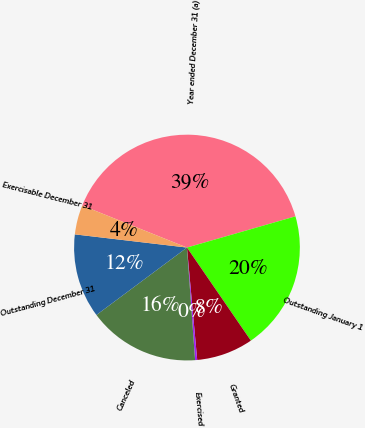<chart> <loc_0><loc_0><loc_500><loc_500><pie_chart><fcel>Year ended December 31 (a)<fcel>Outstanding January 1<fcel>Granted<fcel>Exercised<fcel>Canceled<fcel>Outstanding December 31<fcel>Exercisable December 31<nl><fcel>39.47%<fcel>19.88%<fcel>8.13%<fcel>0.3%<fcel>15.96%<fcel>12.05%<fcel>4.21%<nl></chart> 